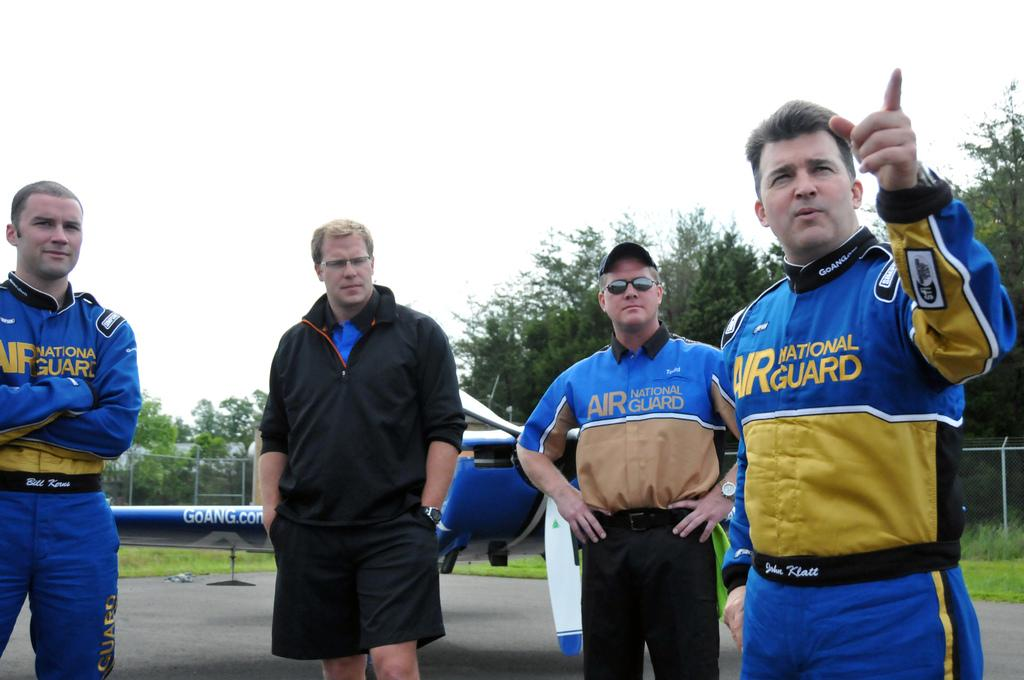<image>
Present a compact description of the photo's key features. Several men are wearing blue uniforms for the Air National Guard. 